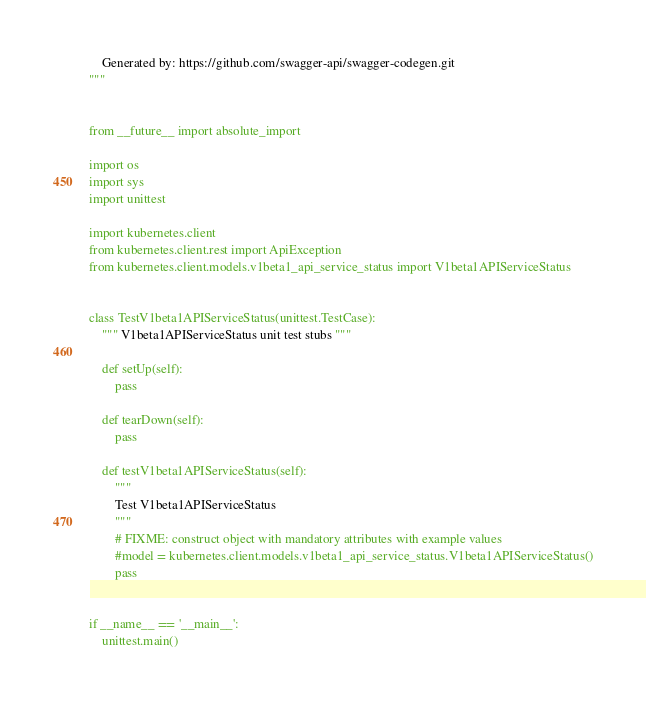<code> <loc_0><loc_0><loc_500><loc_500><_Python_>    Generated by: https://github.com/swagger-api/swagger-codegen.git
"""


from __future__ import absolute_import

import os
import sys
import unittest

import kubernetes.client
from kubernetes.client.rest import ApiException
from kubernetes.client.models.v1beta1_api_service_status import V1beta1APIServiceStatus


class TestV1beta1APIServiceStatus(unittest.TestCase):
    """ V1beta1APIServiceStatus unit test stubs """

    def setUp(self):
        pass

    def tearDown(self):
        pass

    def testV1beta1APIServiceStatus(self):
        """
        Test V1beta1APIServiceStatus
        """
        # FIXME: construct object with mandatory attributes with example values
        #model = kubernetes.client.models.v1beta1_api_service_status.V1beta1APIServiceStatus()
        pass


if __name__ == '__main__':
    unittest.main()
</code> 